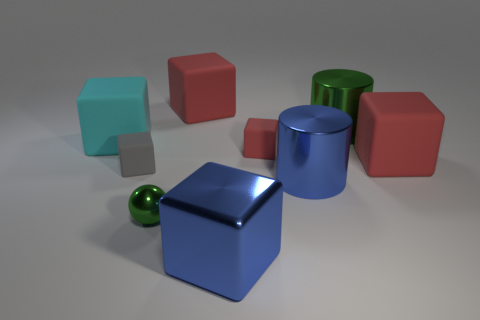Is the tiny metal object the same color as the shiny cube?
Your answer should be very brief. No. What material is the red object that is to the left of the big blue cylinder and in front of the large green shiny cylinder?
Offer a terse response. Rubber. The large metallic cube has what color?
Keep it short and to the point. Blue. What number of large green objects have the same shape as the gray rubber thing?
Your response must be concise. 0. Do the green object behind the cyan cube and the tiny thing in front of the small gray matte object have the same material?
Your answer should be compact. Yes. What is the size of the red rubber thing that is to the right of the green shiny object that is on the right side of the tiny red thing?
Your answer should be very brief. Large. Is there anything else that is the same size as the metallic block?
Keep it short and to the point. Yes. There is a blue thing that is the same shape as the gray object; what material is it?
Offer a very short reply. Metal. Does the tiny red object that is on the left side of the green cylinder have the same shape as the blue metallic thing behind the tiny green metal ball?
Make the answer very short. No. Is the number of tiny red rubber cubes greater than the number of big shiny objects?
Offer a terse response. No. 